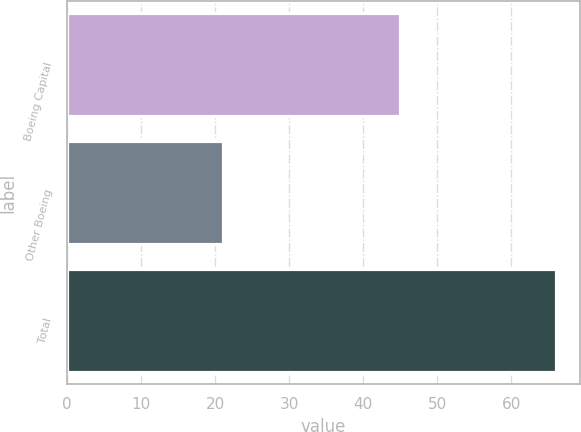<chart> <loc_0><loc_0><loc_500><loc_500><bar_chart><fcel>Boeing Capital<fcel>Other Boeing<fcel>Total<nl><fcel>45<fcel>21<fcel>66<nl></chart> 